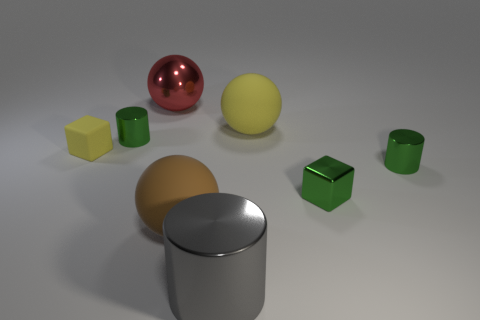Subtract all big brown spheres. How many spheres are left? 2 Subtract 3 cylinders. How many cylinders are left? 0 Add 2 small gray things. How many objects exist? 10 Subtract all red spheres. How many spheres are left? 2 Subtract all spheres. How many objects are left? 5 Subtract all large shiny cylinders. Subtract all red things. How many objects are left? 6 Add 3 large brown rubber objects. How many large brown rubber objects are left? 4 Add 2 metallic cubes. How many metallic cubes exist? 3 Subtract 0 gray cubes. How many objects are left? 8 Subtract all yellow cubes. Subtract all gray cylinders. How many cubes are left? 1 